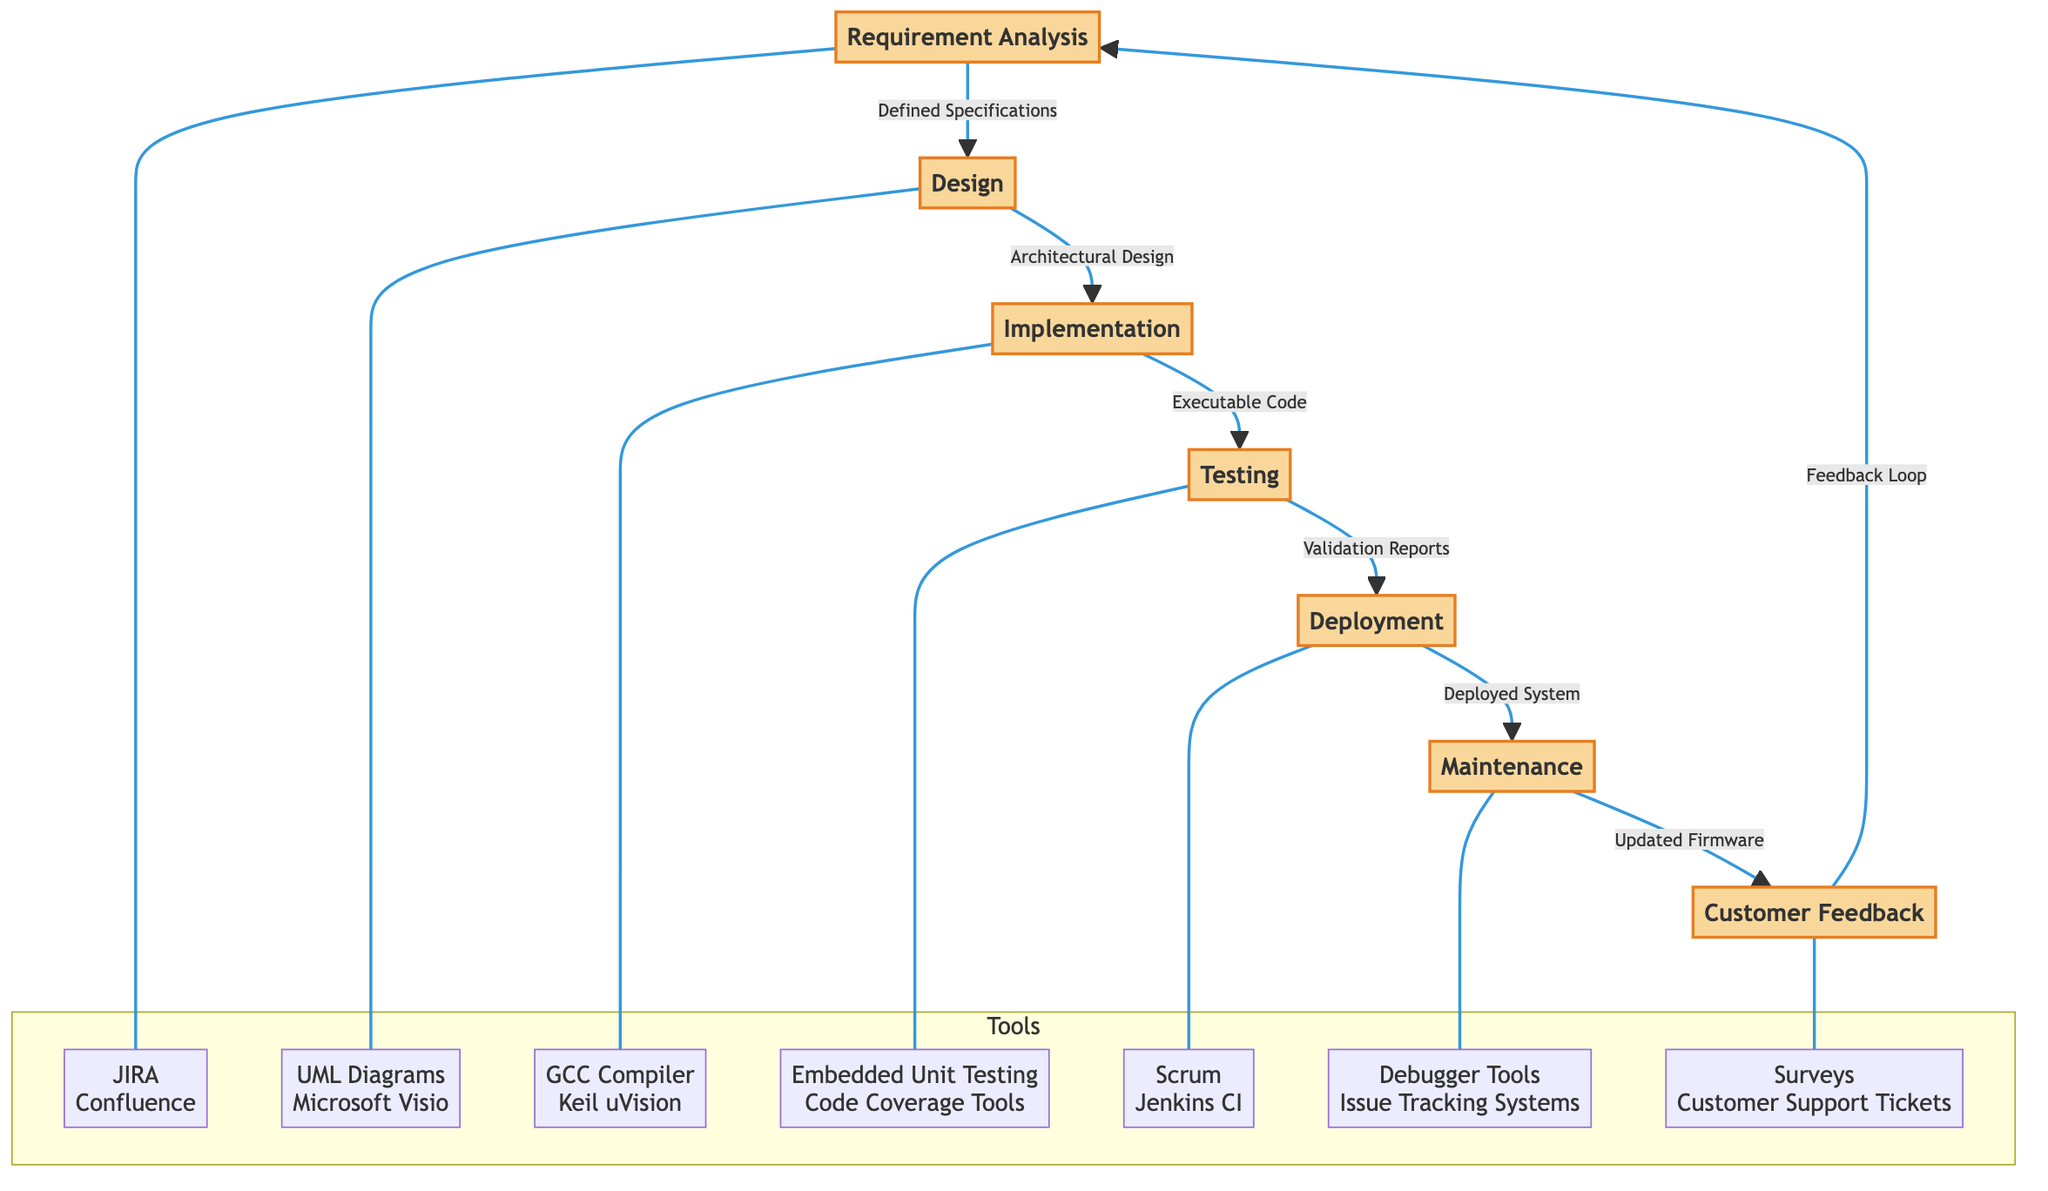What is the first phase in the firmware development lifecycle? The diagram shows "Requirement Analysis" prominently as the starting phase, indicating it is the first step in the lifecycle.
Answer: Requirement Analysis How many key phases are represented in the diagram? By counting the individual phases listed (Requirement Analysis, Design, Implementation, Testing, Deployment, Maintenance, Customer Feedback), we find there are seven phases in total.
Answer: 7 What tool is associated with the Testing phase? The Testing phase is linked to "Embedded Unit Testing" and "Code Coverage Tools", clearly displaying these tools beneath the Testing phase.
Answer: Embedded Unit Testing, Code Coverage Tools What outputs are generated in the Deployment phase? The diagram indicates that the output of the Deployment phase is "Deployed System," which is explicitly stated in the flow between Testing and Deployment.
Answer: Deployed System What is the feedback loop indicated in the diagram? The diagram shows a flow from "Customer Feedback" back to "Requirement Analysis," representing a cyclical nature of feedback that informs the beginning of the development lifecycle.
Answer: Feedback Loop Which design tool is mentioned in the Design phase? The Design phase is associated with "UML Diagrams" and "Microsoft Visio," specifically linked under the Design phase in the tools section.
Answer: UML Diagrams, Microsoft Visio What happens after the Maintenance phase in the diagram? According to the diagram, after the Maintenance phase, the output is "Updated Firmware," which flows into the Customer Feedback phase as a follow-up.
Answer: Updated Firmware How does the diagram depict the relationship between Implementation and Testing? The diagram illustrates a directed arrow from Implementation to Testing, indicating that the output from Implementation, namely "Executable Code," serves as input to the Testing phase.
Answer: Executable Code Which phase utilizes Scrum and Jenkins CI? The Deployment phase is connected with these tools, which are listed directly beneath the Deployment node in the diagram.
Answer: Scrum, Jenkins CI 